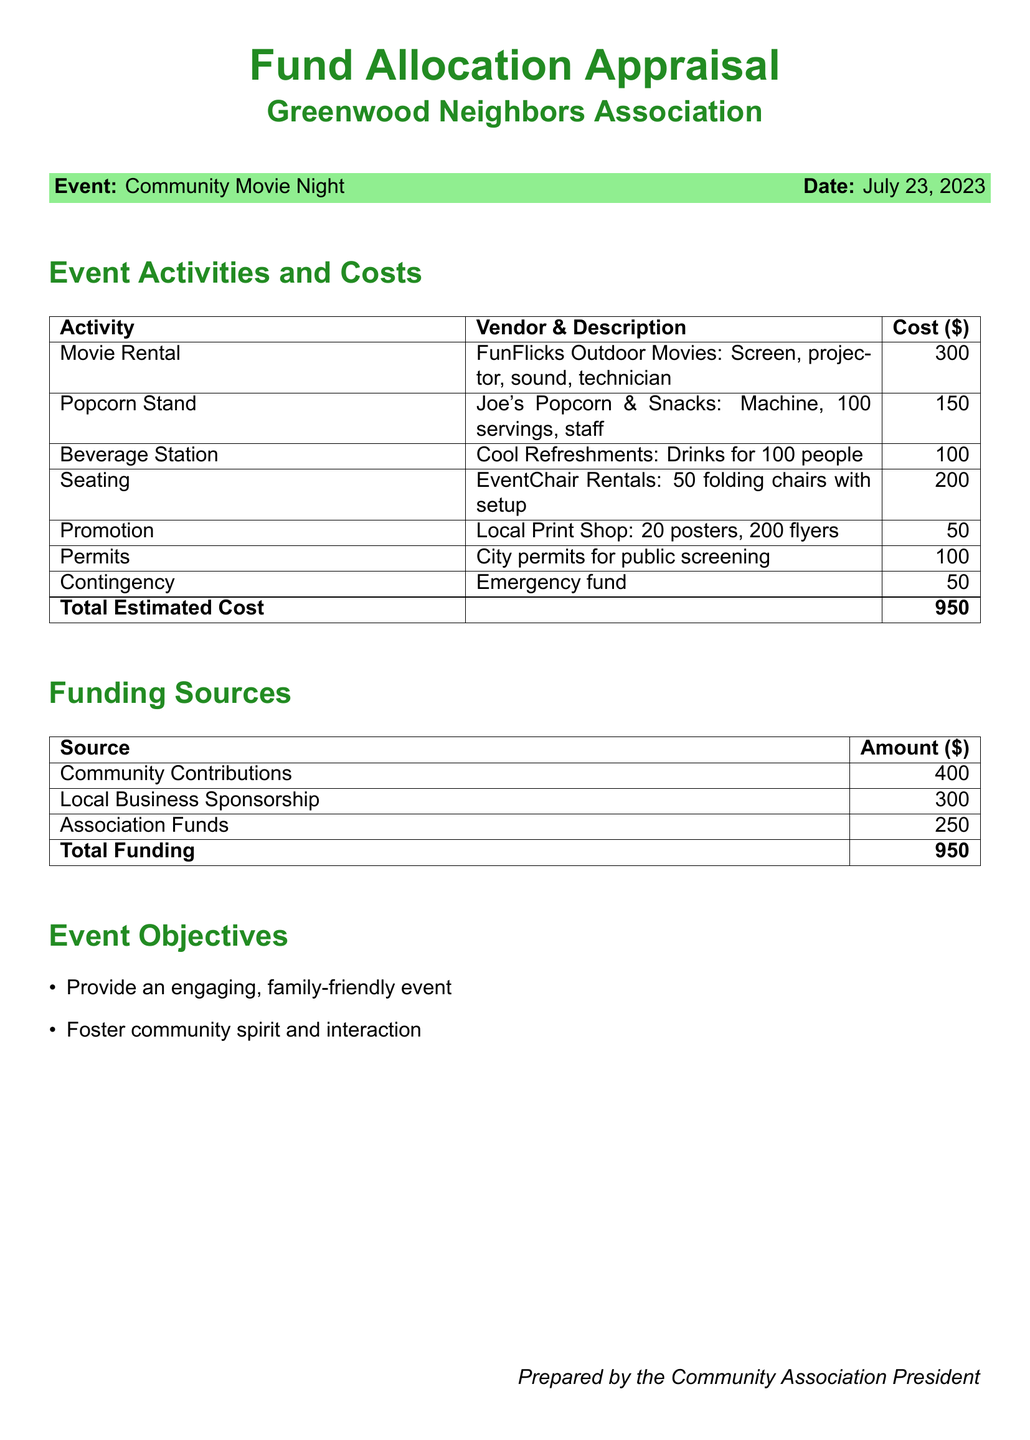what is the date of the Community Movie Night? The date of the event is specified in the document, which is July 23, 2023.
Answer: July 23, 2023 what is the total estimated cost of the event? The total estimated cost is clearly indicated in the document's cost breakdown, totaling $950.
Answer: 950 who is providing the movie rental service? The vendor providing the movie rental is FunFlicks Outdoor Movies.
Answer: FunFlicks Outdoor Movies how much is allocated for the contingency fund? The contingency fund amount is listed in the cost breakdown as $50.
Answer: 50 what are the funding sources listed in the document? The document lists three funding sources: Community Contributions, Local Business Sponsorship, and Association Funds.
Answer: Community Contributions, Local Business Sponsorship, Association Funds what is the cost for the beverage station? The cost associated with the beverage station is provided in the cost table, which is $100.
Answer: 100 what is the purpose of the event? The document highlights that the primary purposes are to provide an engaging event and foster community spirit.
Answer: Provide engaging event and foster community spirit how many chairs are being rented for the event? The document specifies that 50 folding chairs are being rented, as per the cost breakdown.
Answer: 50 which vendor is responsible for the popcorn stand? The vendor responsible for the popcorn stand is Joe's Popcorn & Snacks.
Answer: Joe's Popcorn & Snacks 